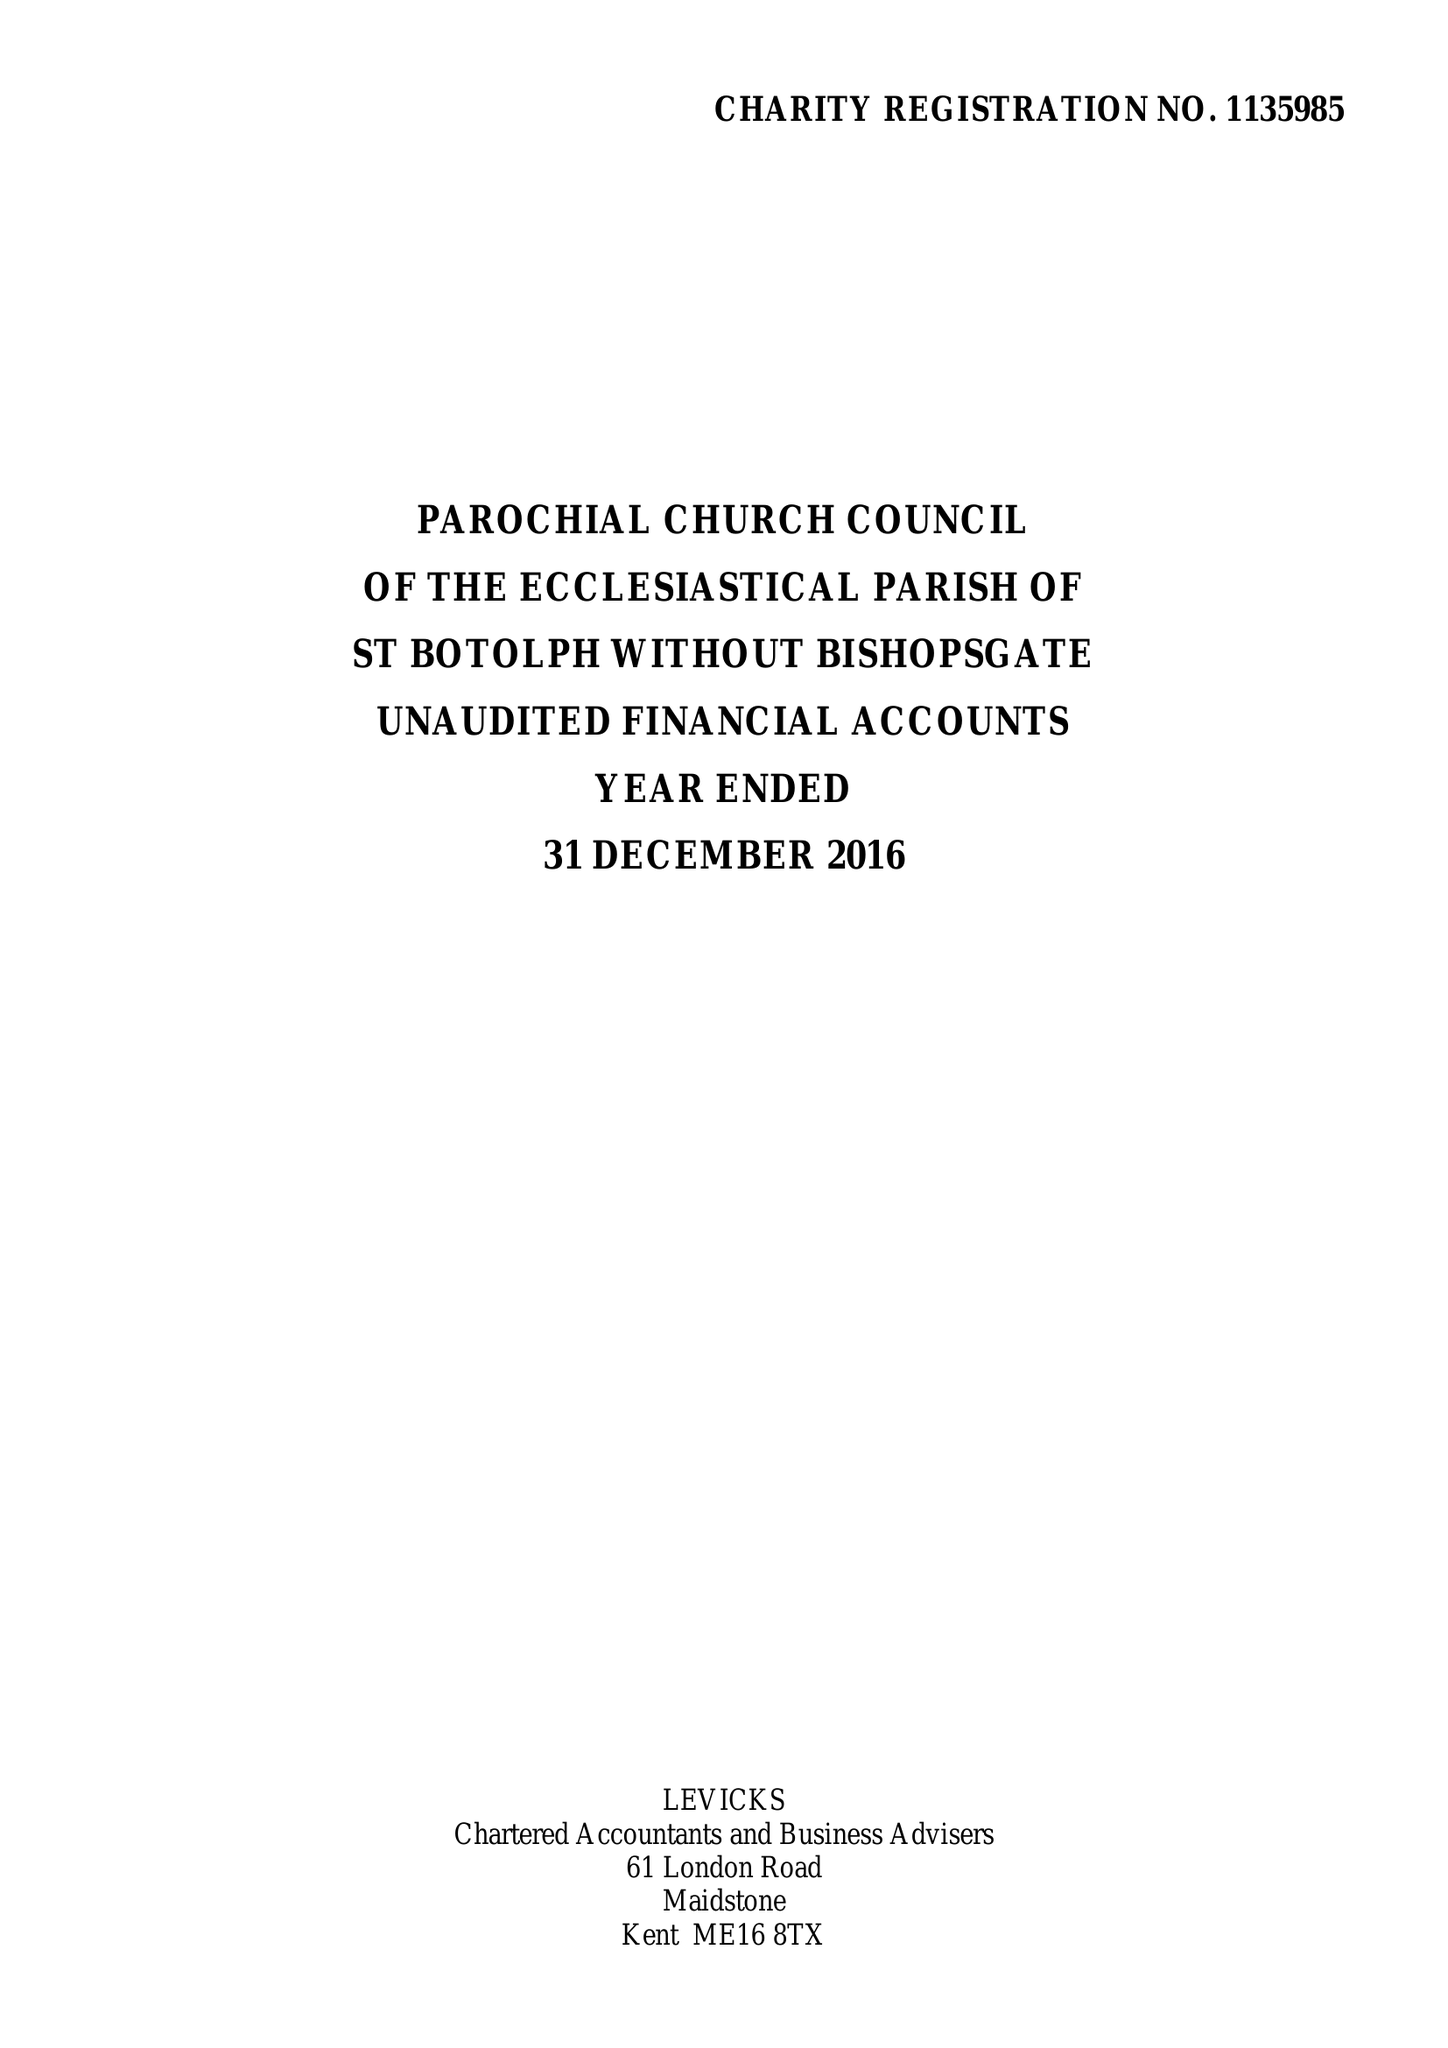What is the value for the charity_name?
Answer the question using a single word or phrase. The Parochial Church Council Of The Ecclesiastical Parish Of St Botolph-Without-Bishopsgate 